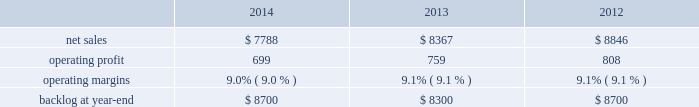Decreased production volume as final aircraft deliveries were completed during the second quarter of 2012 and $ 50 million from the favorable resolution of a contractual matter during the second quarter of 2012 ; and about $ 270 million for various other programs ( primarily sustainment activities ) due to decreased volume .
The decreases were partially offset by higher net sales of about $ 295 million for f-35 production contracts due to increased production volume and risk retirements ; approximately $ 245 million for the c-5 program due to increased aircraft deliveries ( six aircraft delivered in 2013 compared to four in 2012 ) and other modernization activities ; and about $ 70 million for the f-35 development contract due to increased volume .
Aeronautics 2019 operating profit for 2013 decreased $ 87 million , or 5% ( 5 % ) , compared to 2012 .
The decrease was primarily attributable to lower operating profit of about $ 85 million for the f-22 program , which includes approximately $ 50 million from the favorable resolution of a contractual matter in the second quarter of 2012 and about $ 35 million due to decreased risk retirements and production volume ; approximately $ 70 million for the c-130 program due to lower risk retirements and fewer deliveries partially offset by increased sustainment activities ; about $ 65 million for the c-5 program due to the inception-to-date effect of reducing the profit booking rate in the third quarter of 2013 and lower risk retirements ; approximately $ 35 million for the f-16 program due to fewer aircraft deliveries partially offset by increased sustainment activity and aircraft configuration mix .
The decreases were partially offset by higher operating profit of approximately $ 180 million for f-35 production contracts due to increased risk retirements and volume .
Operating profit was comparable for the f-35 development contract and included adjustments of approximately $ 85 million to reflect the inception-to-date impacts of the downward revisions to the profit booking rate in both 2013 and 2012 .
Adjustments not related to volume , including net profit booking rate adjustments and other matters , were approximately $ 75 million lower for 2013 compared to backlog backlog decreased slightly in 2014 compared to 2013 primarily due to lower orders on f-16 and f-22 programs .
Backlog decreased in 2013 compared to 2012 mainly due to lower orders on f-16 , c-5 and c-130 programs , partially offset by higher orders on the f-35 program .
Trends we expect aeronautics 2019 2015 net sales to be comparable or slightly behind 2014 due to a decline in f-16 deliveries as well as a decline in f-35 development activity , partially offset by an increase in production contracts .
Operating profit is also expected to decrease in the low single digit range , due primarily to contract mix , resulting in a slight decrease in operating margins between years .
Information systems & global solutions our is&gs business segment provides advanced technology systems and expertise , integrated information technology solutions and management services across a broad spectrum of applications for civil , defense , intelligence and other government customers .
Is&gs has a portfolio of many smaller contracts as compared to our other business segments .
Is&gs has been impacted by the continued downturn in certain federal agencies 2019 information technology budgets and increased re-competition on existing contracts coupled with the fragmentation of large contracts into multiple smaller contracts that are awarded primarily on the basis of price .
Is&gs 2019 operating results included the following ( in millions ) : .
2014 compared to 2013 is&gs 2019 net sales decreased $ 579 million , or 7% ( 7 % ) , for 2014 compared to 2013 .
The decrease was primarily attributable to lower net sales of about $ 645 million for 2014 due to the wind-down or completion of certain programs , driven by reductions in direct warfighter support ( including jieddo and ptds ) and defense budgets tied to command and control programs ; and approximately $ 490 million for 2014 due to a decline in volume for various ongoing programs , which reflects lower funding levels and programs impacted by in-theater force reductions .
The decreases were partially offset by higher net sales of about $ 550 million for 2014 due to the start-up of new programs , growth in recently awarded programs and integration of recently acquired companies. .
What was the percent of the net sales from 2012 to 2013? 
Computations: ((8367 - 8846) / 8846)
Answer: -0.05415. Decreased production volume as final aircraft deliveries were completed during the second quarter of 2012 and $ 50 million from the favorable resolution of a contractual matter during the second quarter of 2012 ; and about $ 270 million for various other programs ( primarily sustainment activities ) due to decreased volume .
The decreases were partially offset by higher net sales of about $ 295 million for f-35 production contracts due to increased production volume and risk retirements ; approximately $ 245 million for the c-5 program due to increased aircraft deliveries ( six aircraft delivered in 2013 compared to four in 2012 ) and other modernization activities ; and about $ 70 million for the f-35 development contract due to increased volume .
Aeronautics 2019 operating profit for 2013 decreased $ 87 million , or 5% ( 5 % ) , compared to 2012 .
The decrease was primarily attributable to lower operating profit of about $ 85 million for the f-22 program , which includes approximately $ 50 million from the favorable resolution of a contractual matter in the second quarter of 2012 and about $ 35 million due to decreased risk retirements and production volume ; approximately $ 70 million for the c-130 program due to lower risk retirements and fewer deliveries partially offset by increased sustainment activities ; about $ 65 million for the c-5 program due to the inception-to-date effect of reducing the profit booking rate in the third quarter of 2013 and lower risk retirements ; approximately $ 35 million for the f-16 program due to fewer aircraft deliveries partially offset by increased sustainment activity and aircraft configuration mix .
The decreases were partially offset by higher operating profit of approximately $ 180 million for f-35 production contracts due to increased risk retirements and volume .
Operating profit was comparable for the f-35 development contract and included adjustments of approximately $ 85 million to reflect the inception-to-date impacts of the downward revisions to the profit booking rate in both 2013 and 2012 .
Adjustments not related to volume , including net profit booking rate adjustments and other matters , were approximately $ 75 million lower for 2013 compared to backlog backlog decreased slightly in 2014 compared to 2013 primarily due to lower orders on f-16 and f-22 programs .
Backlog decreased in 2013 compared to 2012 mainly due to lower orders on f-16 , c-5 and c-130 programs , partially offset by higher orders on the f-35 program .
Trends we expect aeronautics 2019 2015 net sales to be comparable or slightly behind 2014 due to a decline in f-16 deliveries as well as a decline in f-35 development activity , partially offset by an increase in production contracts .
Operating profit is also expected to decrease in the low single digit range , due primarily to contract mix , resulting in a slight decrease in operating margins between years .
Information systems & global solutions our is&gs business segment provides advanced technology systems and expertise , integrated information technology solutions and management services across a broad spectrum of applications for civil , defense , intelligence and other government customers .
Is&gs has a portfolio of many smaller contracts as compared to our other business segments .
Is&gs has been impacted by the continued downturn in certain federal agencies 2019 information technology budgets and increased re-competition on existing contracts coupled with the fragmentation of large contracts into multiple smaller contracts that are awarded primarily on the basis of price .
Is&gs 2019 operating results included the following ( in millions ) : .
2014 compared to 2013 is&gs 2019 net sales decreased $ 579 million , or 7% ( 7 % ) , for 2014 compared to 2013 .
The decrease was primarily attributable to lower net sales of about $ 645 million for 2014 due to the wind-down or completion of certain programs , driven by reductions in direct warfighter support ( including jieddo and ptds ) and defense budgets tied to command and control programs ; and approximately $ 490 million for 2014 due to a decline in volume for various ongoing programs , which reflects lower funding levels and programs impacted by in-theater force reductions .
The decreases were partially offset by higher net sales of about $ 550 million for 2014 due to the start-up of new programs , growth in recently awarded programs and integration of recently acquired companies. .
What is the growth rate in operating profit from 2013 to 2014 for is&gs? 
Computations: ((699 - 759) / 759)
Answer: -0.07905. Decreased production volume as final aircraft deliveries were completed during the second quarter of 2012 and $ 50 million from the favorable resolution of a contractual matter during the second quarter of 2012 ; and about $ 270 million for various other programs ( primarily sustainment activities ) due to decreased volume .
The decreases were partially offset by higher net sales of about $ 295 million for f-35 production contracts due to increased production volume and risk retirements ; approximately $ 245 million for the c-5 program due to increased aircraft deliveries ( six aircraft delivered in 2013 compared to four in 2012 ) and other modernization activities ; and about $ 70 million for the f-35 development contract due to increased volume .
Aeronautics 2019 operating profit for 2013 decreased $ 87 million , or 5% ( 5 % ) , compared to 2012 .
The decrease was primarily attributable to lower operating profit of about $ 85 million for the f-22 program , which includes approximately $ 50 million from the favorable resolution of a contractual matter in the second quarter of 2012 and about $ 35 million due to decreased risk retirements and production volume ; approximately $ 70 million for the c-130 program due to lower risk retirements and fewer deliveries partially offset by increased sustainment activities ; about $ 65 million for the c-5 program due to the inception-to-date effect of reducing the profit booking rate in the third quarter of 2013 and lower risk retirements ; approximately $ 35 million for the f-16 program due to fewer aircraft deliveries partially offset by increased sustainment activity and aircraft configuration mix .
The decreases were partially offset by higher operating profit of approximately $ 180 million for f-35 production contracts due to increased risk retirements and volume .
Operating profit was comparable for the f-35 development contract and included adjustments of approximately $ 85 million to reflect the inception-to-date impacts of the downward revisions to the profit booking rate in both 2013 and 2012 .
Adjustments not related to volume , including net profit booking rate adjustments and other matters , were approximately $ 75 million lower for 2013 compared to backlog backlog decreased slightly in 2014 compared to 2013 primarily due to lower orders on f-16 and f-22 programs .
Backlog decreased in 2013 compared to 2012 mainly due to lower orders on f-16 , c-5 and c-130 programs , partially offset by higher orders on the f-35 program .
Trends we expect aeronautics 2019 2015 net sales to be comparable or slightly behind 2014 due to a decline in f-16 deliveries as well as a decline in f-35 development activity , partially offset by an increase in production contracts .
Operating profit is also expected to decrease in the low single digit range , due primarily to contract mix , resulting in a slight decrease in operating margins between years .
Information systems & global solutions our is&gs business segment provides advanced technology systems and expertise , integrated information technology solutions and management services across a broad spectrum of applications for civil , defense , intelligence and other government customers .
Is&gs has a portfolio of many smaller contracts as compared to our other business segments .
Is&gs has been impacted by the continued downturn in certain federal agencies 2019 information technology budgets and increased re-competition on existing contracts coupled with the fragmentation of large contracts into multiple smaller contracts that are awarded primarily on the basis of price .
Is&gs 2019 operating results included the following ( in millions ) : .
2014 compared to 2013 is&gs 2019 net sales decreased $ 579 million , or 7% ( 7 % ) , for 2014 compared to 2013 .
The decrease was primarily attributable to lower net sales of about $ 645 million for 2014 due to the wind-down or completion of certain programs , driven by reductions in direct warfighter support ( including jieddo and ptds ) and defense budgets tied to command and control programs ; and approximately $ 490 million for 2014 due to a decline in volume for various ongoing programs , which reflects lower funding levels and programs impacted by in-theater force reductions .
The decreases were partially offset by higher net sales of about $ 550 million for 2014 due to the start-up of new programs , growth in recently awarded programs and integration of recently acquired companies. .
What is the growth rate in operating profit from 2012 to 2013 for is&gs? 
Computations: ((759 - 808) / 808)
Answer: -0.06064. 